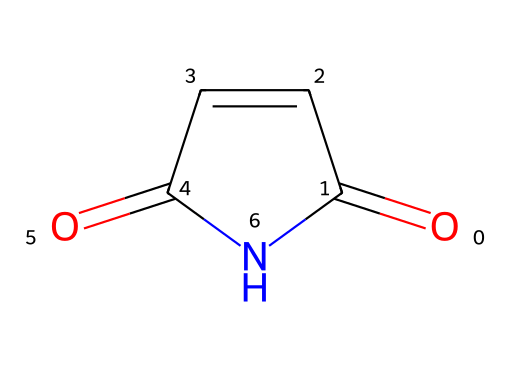How many carbon atoms are in maleimide? By analyzing the SMILES representation O=C1C=CC(=O)N1, we can identify all the carbon atoms present. There are three carbon atoms (C) indicated in the structure.
Answer: three What is the functional group present in maleimide? Upon examining the structure, we see the presence of an imide functional group, characterized by the carbonyl (C=O) connected to nitrogen (N).
Answer: imide How many nitrogen atoms are in maleimide? The SMILES representation indicates one nitrogen atom (N) connected to the carbon atoms. Counting reveals there is only one nitrogen present.
Answer: one What types of bonds are present in maleimide? By interpreting the structure, we can identify both double bonds (between C=C and C=O) and single bonds (between C and N). Thus, both types of bonds are found.
Answer: both What is the molecular formula of maleimide? To derive the molecular formula, we count the atoms: 4 carbon (C), 4 hydrogen (H), 1 nitrogen (N), and 2 oxygen (O) give us C4H4N2O2, summarizing the composition of the compound.
Answer: C4H4N2O2 Is maleimide a cyclic compound? Observing the structure, we see that it contains a ring (indicated by the '1' in the SMILES), confirming the compound is indeed cyclic.
Answer: yes 